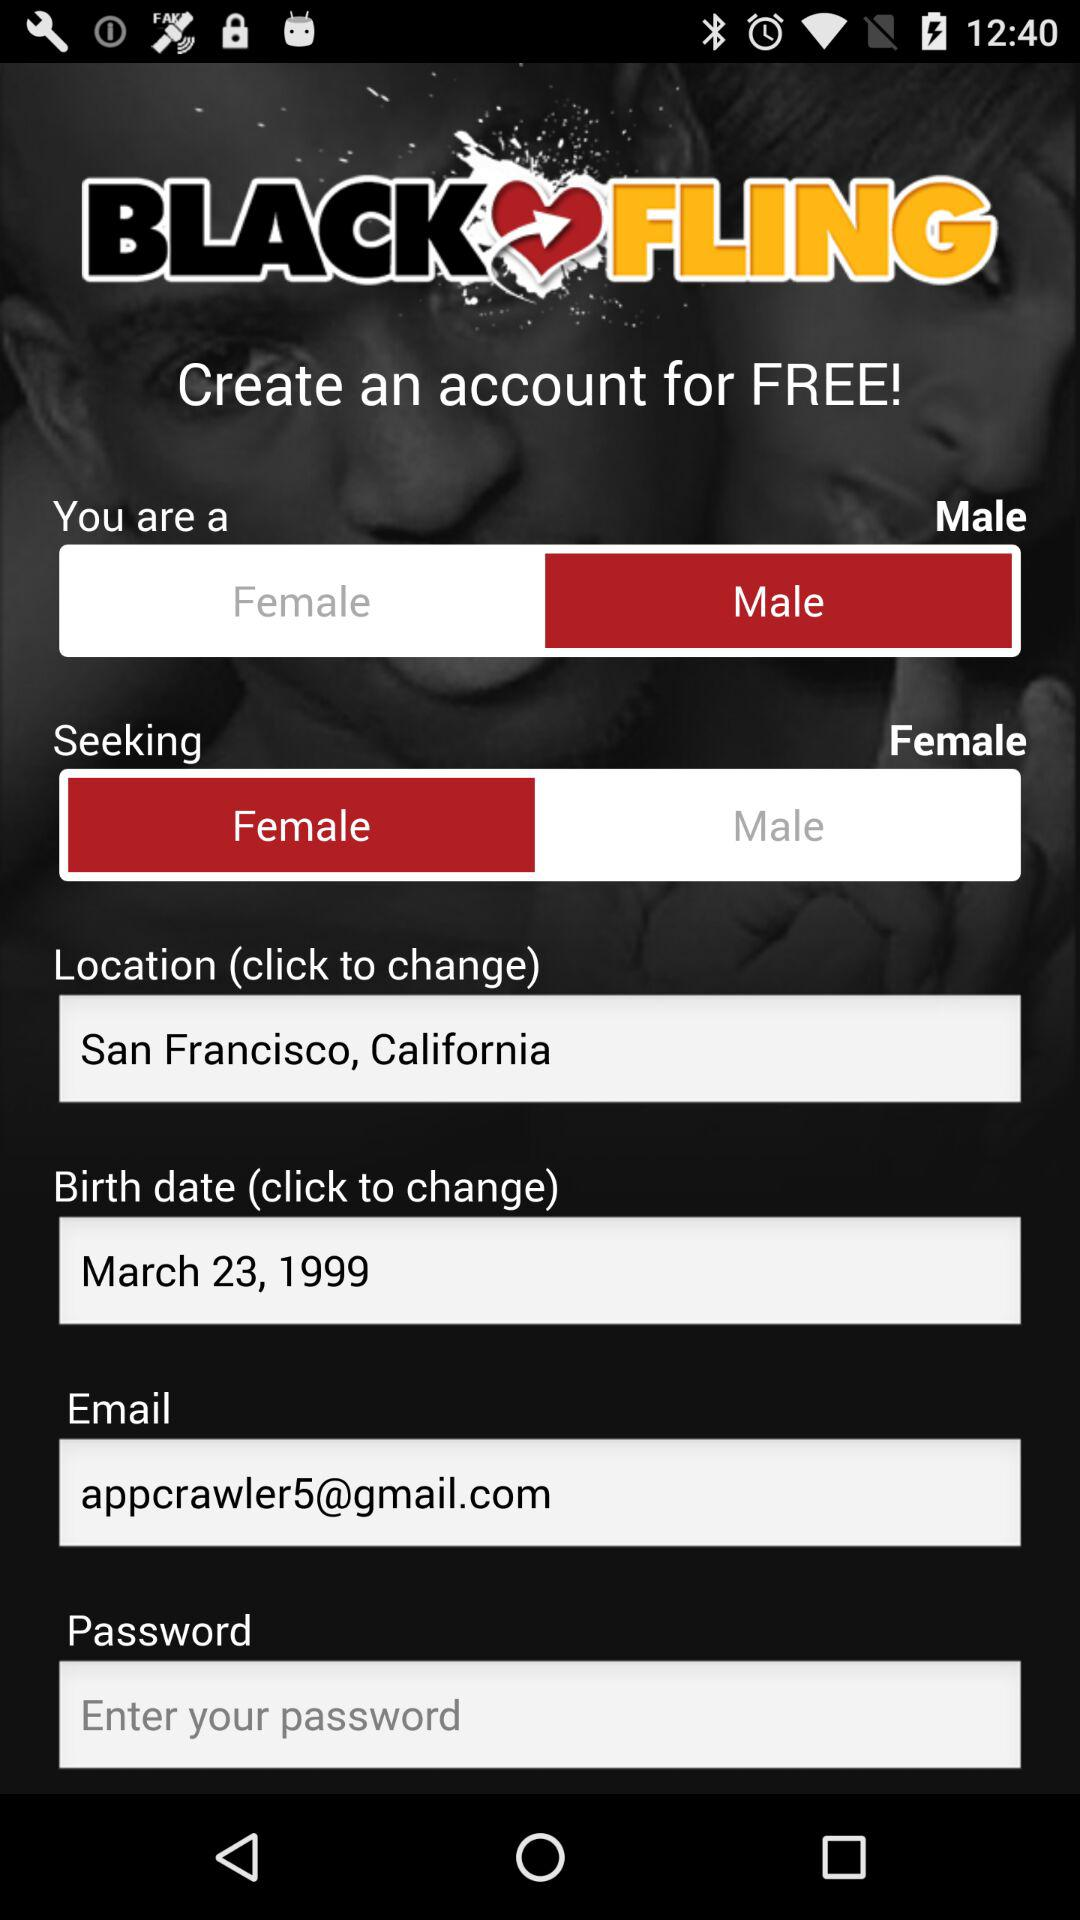Which seek is selected?
When the provided information is insufficient, respond with <no answer>. <no answer> 